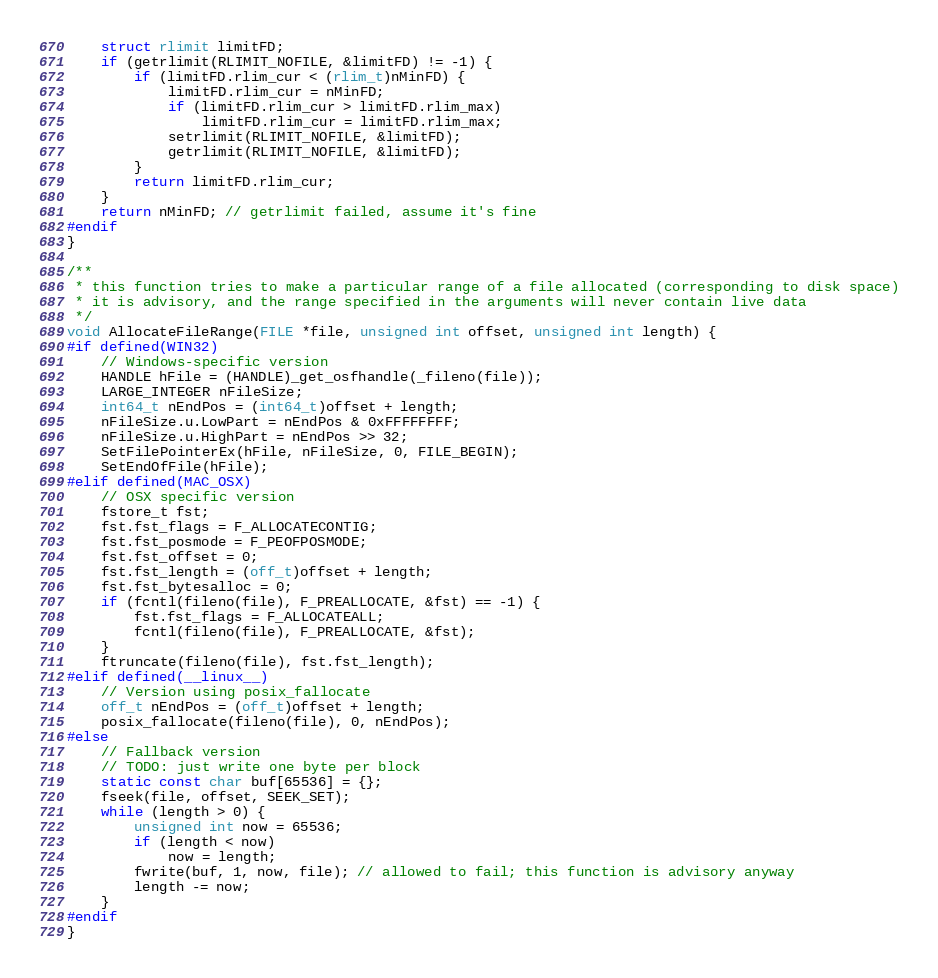<code> <loc_0><loc_0><loc_500><loc_500><_C++_>    struct rlimit limitFD;
    if (getrlimit(RLIMIT_NOFILE, &limitFD) != -1) {
        if (limitFD.rlim_cur < (rlim_t)nMinFD) {
            limitFD.rlim_cur = nMinFD;
            if (limitFD.rlim_cur > limitFD.rlim_max)
                limitFD.rlim_cur = limitFD.rlim_max;
            setrlimit(RLIMIT_NOFILE, &limitFD);
            getrlimit(RLIMIT_NOFILE, &limitFD);
        }
        return limitFD.rlim_cur;
    }
    return nMinFD; // getrlimit failed, assume it's fine
#endif
}

/**
 * this function tries to make a particular range of a file allocated (corresponding to disk space)
 * it is advisory, and the range specified in the arguments will never contain live data
 */
void AllocateFileRange(FILE *file, unsigned int offset, unsigned int length) {
#if defined(WIN32)
    // Windows-specific version
    HANDLE hFile = (HANDLE)_get_osfhandle(_fileno(file));
    LARGE_INTEGER nFileSize;
    int64_t nEndPos = (int64_t)offset + length;
    nFileSize.u.LowPart = nEndPos & 0xFFFFFFFF;
    nFileSize.u.HighPart = nEndPos >> 32;
    SetFilePointerEx(hFile, nFileSize, 0, FILE_BEGIN);
    SetEndOfFile(hFile);
#elif defined(MAC_OSX)
    // OSX specific version
    fstore_t fst;
    fst.fst_flags = F_ALLOCATECONTIG;
    fst.fst_posmode = F_PEOFPOSMODE;
    fst.fst_offset = 0;
    fst.fst_length = (off_t)offset + length;
    fst.fst_bytesalloc = 0;
    if (fcntl(fileno(file), F_PREALLOCATE, &fst) == -1) {
        fst.fst_flags = F_ALLOCATEALL;
        fcntl(fileno(file), F_PREALLOCATE, &fst);
    }
    ftruncate(fileno(file), fst.fst_length);
#elif defined(__linux__)
    // Version using posix_fallocate
    off_t nEndPos = (off_t)offset + length;
    posix_fallocate(fileno(file), 0, nEndPos);
#else
    // Fallback version
    // TODO: just write one byte per block
    static const char buf[65536] = {};
    fseek(file, offset, SEEK_SET);
    while (length > 0) {
        unsigned int now = 65536;
        if (length < now)
            now = length;
        fwrite(buf, 1, now, file); // allowed to fail; this function is advisory anyway
        length -= now;
    }
#endif
}
</code> 